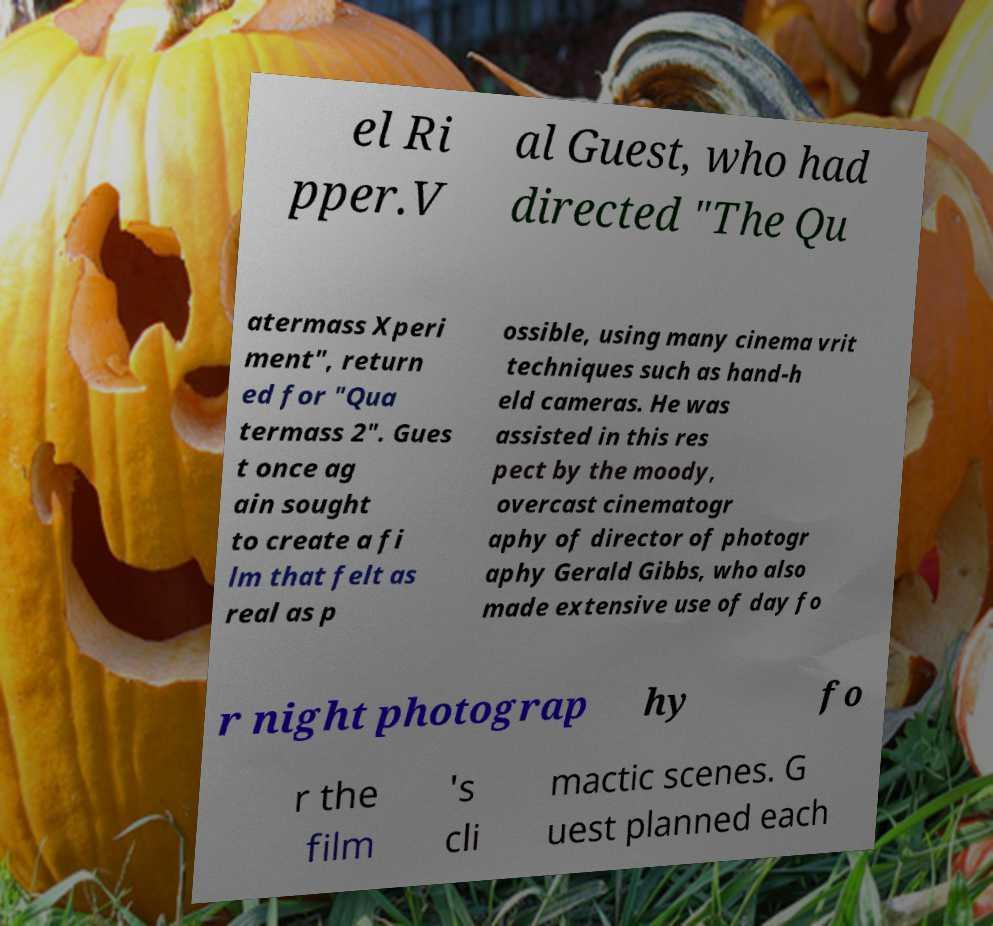Please read and relay the text visible in this image. What does it say? el Ri pper.V al Guest, who had directed "The Qu atermass Xperi ment", return ed for "Qua termass 2". Gues t once ag ain sought to create a fi lm that felt as real as p ossible, using many cinema vrit techniques such as hand-h eld cameras. He was assisted in this res pect by the moody, overcast cinematogr aphy of director of photogr aphy Gerald Gibbs, who also made extensive use of day fo r night photograp hy fo r the film 's cli mactic scenes. G uest planned each 